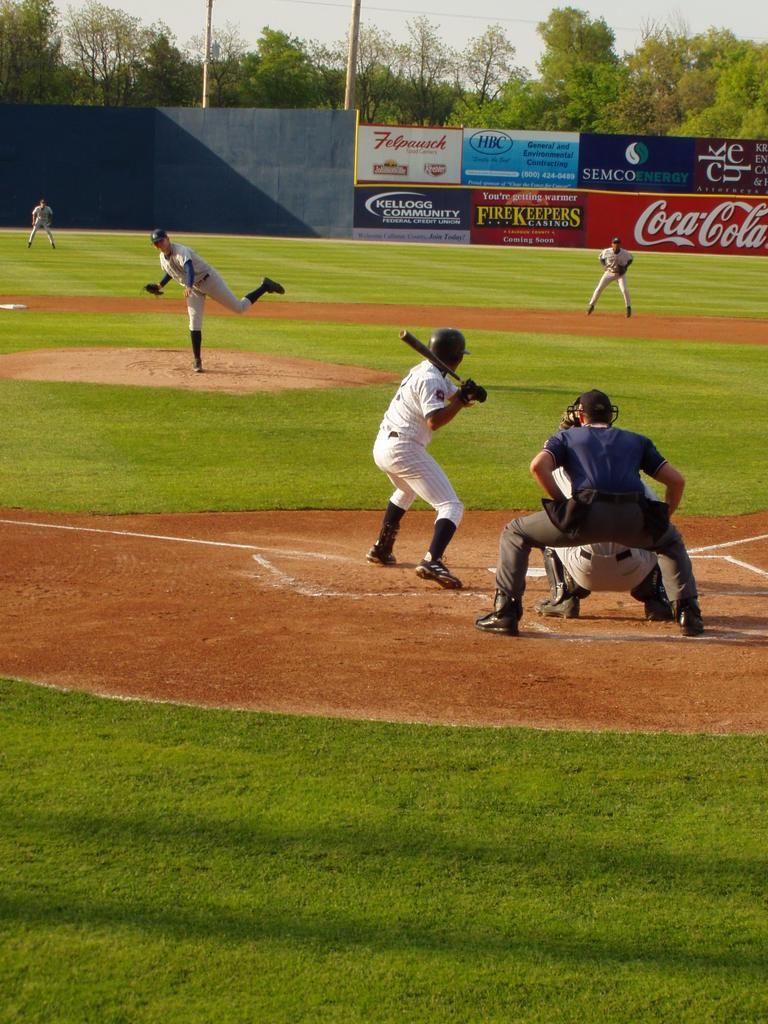Could you give a brief overview of what you see in this image? In this picture we can see some people on the ground were a man holding a bat with his hands and they wore shoes, helmets and in the background we can see banners, trees, poles, sky. 